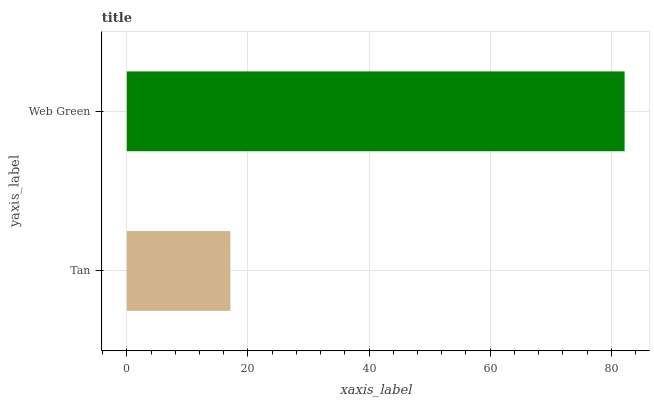Is Tan the minimum?
Answer yes or no. Yes. Is Web Green the maximum?
Answer yes or no. Yes. Is Web Green the minimum?
Answer yes or no. No. Is Web Green greater than Tan?
Answer yes or no. Yes. Is Tan less than Web Green?
Answer yes or no. Yes. Is Tan greater than Web Green?
Answer yes or no. No. Is Web Green less than Tan?
Answer yes or no. No. Is Web Green the high median?
Answer yes or no. Yes. Is Tan the low median?
Answer yes or no. Yes. Is Tan the high median?
Answer yes or no. No. Is Web Green the low median?
Answer yes or no. No. 